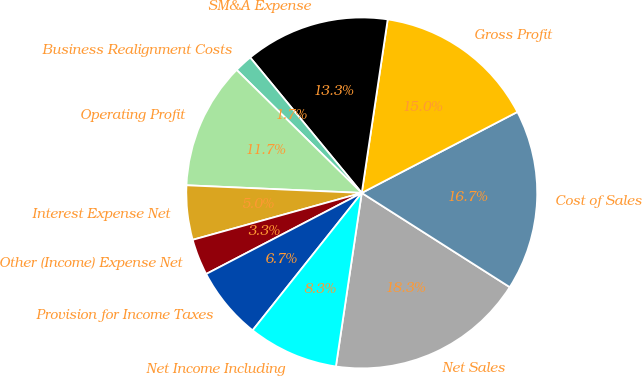Convert chart. <chart><loc_0><loc_0><loc_500><loc_500><pie_chart><fcel>Net Sales<fcel>Cost of Sales<fcel>Gross Profit<fcel>SM&A Expense<fcel>Business Realignment Costs<fcel>Operating Profit<fcel>Interest Expense Net<fcel>Other (Income) Expense Net<fcel>Provision for Income Taxes<fcel>Net Income Including<nl><fcel>18.33%<fcel>16.66%<fcel>15.0%<fcel>13.33%<fcel>1.67%<fcel>11.67%<fcel>5.0%<fcel>3.34%<fcel>6.67%<fcel>8.33%<nl></chart> 